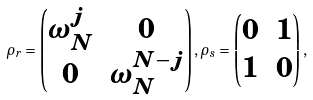Convert formula to latex. <formula><loc_0><loc_0><loc_500><loc_500>\rho _ { r } = \begin{pmatrix} \omega _ { N } ^ { j } & 0 \\ 0 & \omega _ { N } ^ { N - { j } } \end{pmatrix} , \rho _ { s } = \begin{pmatrix} 0 & 1 \\ 1 & 0 \end{pmatrix} ,</formula> 